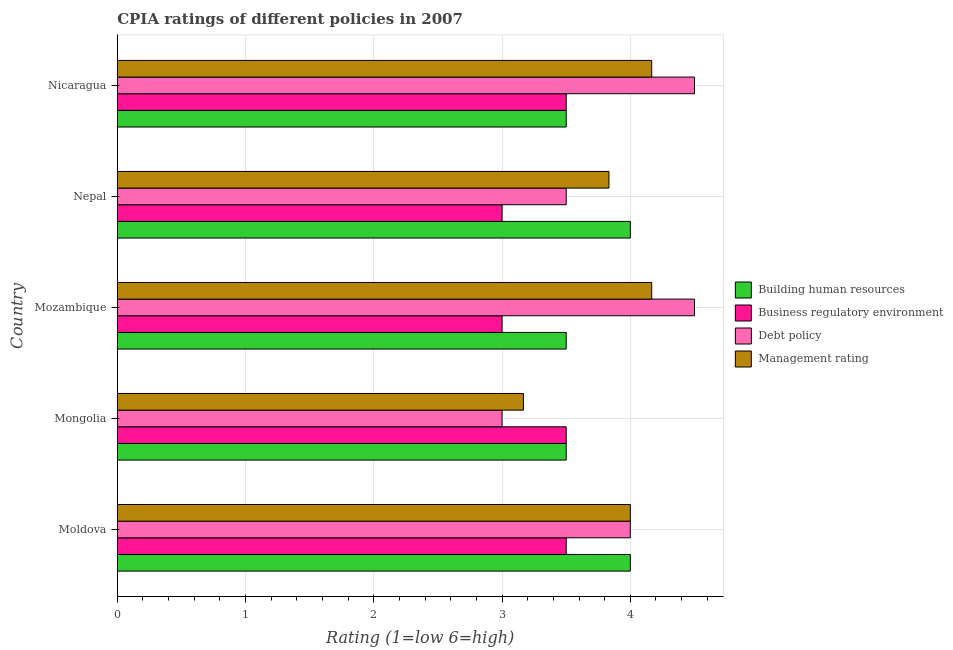How many different coloured bars are there?
Provide a short and direct response. 4. How many groups of bars are there?
Offer a very short reply. 5. Are the number of bars per tick equal to the number of legend labels?
Provide a short and direct response. Yes. How many bars are there on the 2nd tick from the top?
Offer a terse response. 4. How many bars are there on the 5th tick from the bottom?
Your answer should be very brief. 4. What is the label of the 1st group of bars from the top?
Make the answer very short. Nicaragua. What is the cpia rating of management in Moldova?
Keep it short and to the point. 4. Across all countries, what is the maximum cpia rating of building human resources?
Give a very brief answer. 4. In which country was the cpia rating of business regulatory environment maximum?
Make the answer very short. Moldova. In which country was the cpia rating of business regulatory environment minimum?
Offer a very short reply. Mozambique. What is the difference between the cpia rating of management in Mongolia and that in Nepal?
Offer a very short reply. -0.67. What is the difference between the cpia rating of business regulatory environment in Nepal and the cpia rating of building human resources in Nicaragua?
Give a very brief answer. -0.5. What is the average cpia rating of building human resources per country?
Offer a very short reply. 3.7. Is the cpia rating of debt policy in Mongolia less than that in Mozambique?
Provide a succinct answer. Yes. Is the difference between the cpia rating of management in Mongolia and Nicaragua greater than the difference between the cpia rating of business regulatory environment in Mongolia and Nicaragua?
Ensure brevity in your answer.  No. What is the difference between the highest and the second highest cpia rating of building human resources?
Give a very brief answer. 0. What is the difference between the highest and the lowest cpia rating of building human resources?
Offer a very short reply. 0.5. Is the sum of the cpia rating of building human resources in Mozambique and Nepal greater than the maximum cpia rating of management across all countries?
Provide a short and direct response. Yes. What does the 2nd bar from the top in Mongolia represents?
Your answer should be very brief. Debt policy. What does the 2nd bar from the bottom in Nepal represents?
Your answer should be compact. Business regulatory environment. How many bars are there?
Make the answer very short. 20. How many countries are there in the graph?
Provide a succinct answer. 5. What is the difference between two consecutive major ticks on the X-axis?
Provide a succinct answer. 1. Does the graph contain grids?
Your answer should be very brief. Yes. Where does the legend appear in the graph?
Provide a succinct answer. Center right. How are the legend labels stacked?
Your response must be concise. Vertical. What is the title of the graph?
Your response must be concise. CPIA ratings of different policies in 2007. What is the label or title of the X-axis?
Keep it short and to the point. Rating (1=low 6=high). What is the label or title of the Y-axis?
Your response must be concise. Country. What is the Rating (1=low 6=high) in Business regulatory environment in Moldova?
Provide a short and direct response. 3.5. What is the Rating (1=low 6=high) in Management rating in Moldova?
Give a very brief answer. 4. What is the Rating (1=low 6=high) in Building human resources in Mongolia?
Provide a succinct answer. 3.5. What is the Rating (1=low 6=high) of Management rating in Mongolia?
Give a very brief answer. 3.17. What is the Rating (1=low 6=high) in Debt policy in Mozambique?
Ensure brevity in your answer.  4.5. What is the Rating (1=low 6=high) of Management rating in Mozambique?
Keep it short and to the point. 4.17. What is the Rating (1=low 6=high) of Building human resources in Nepal?
Make the answer very short. 4. What is the Rating (1=low 6=high) of Debt policy in Nepal?
Give a very brief answer. 3.5. What is the Rating (1=low 6=high) of Management rating in Nepal?
Ensure brevity in your answer.  3.83. What is the Rating (1=low 6=high) of Building human resources in Nicaragua?
Ensure brevity in your answer.  3.5. What is the Rating (1=low 6=high) of Business regulatory environment in Nicaragua?
Ensure brevity in your answer.  3.5. What is the Rating (1=low 6=high) in Management rating in Nicaragua?
Ensure brevity in your answer.  4.17. Across all countries, what is the maximum Rating (1=low 6=high) of Management rating?
Provide a short and direct response. 4.17. Across all countries, what is the minimum Rating (1=low 6=high) in Management rating?
Keep it short and to the point. 3.17. What is the total Rating (1=low 6=high) of Building human resources in the graph?
Your response must be concise. 18.5. What is the total Rating (1=low 6=high) of Business regulatory environment in the graph?
Give a very brief answer. 16.5. What is the total Rating (1=low 6=high) in Debt policy in the graph?
Offer a very short reply. 19.5. What is the total Rating (1=low 6=high) in Management rating in the graph?
Make the answer very short. 19.33. What is the difference between the Rating (1=low 6=high) in Debt policy in Moldova and that in Mongolia?
Offer a terse response. 1. What is the difference between the Rating (1=low 6=high) of Building human resources in Moldova and that in Mozambique?
Give a very brief answer. 0.5. What is the difference between the Rating (1=low 6=high) in Debt policy in Moldova and that in Mozambique?
Keep it short and to the point. -0.5. What is the difference between the Rating (1=low 6=high) of Business regulatory environment in Moldova and that in Nepal?
Offer a terse response. 0.5. What is the difference between the Rating (1=low 6=high) of Debt policy in Moldova and that in Nepal?
Your response must be concise. 0.5. What is the difference between the Rating (1=low 6=high) in Management rating in Moldova and that in Nepal?
Your answer should be compact. 0.17. What is the difference between the Rating (1=low 6=high) in Business regulatory environment in Moldova and that in Nicaragua?
Make the answer very short. 0. What is the difference between the Rating (1=low 6=high) of Debt policy in Moldova and that in Nicaragua?
Provide a succinct answer. -0.5. What is the difference between the Rating (1=low 6=high) of Management rating in Moldova and that in Nicaragua?
Your answer should be very brief. -0.17. What is the difference between the Rating (1=low 6=high) in Business regulatory environment in Mongolia and that in Mozambique?
Provide a succinct answer. 0.5. What is the difference between the Rating (1=low 6=high) of Building human resources in Mongolia and that in Nepal?
Provide a short and direct response. -0.5. What is the difference between the Rating (1=low 6=high) of Debt policy in Mongolia and that in Nepal?
Your response must be concise. -0.5. What is the difference between the Rating (1=low 6=high) of Management rating in Mongolia and that in Nepal?
Keep it short and to the point. -0.67. What is the difference between the Rating (1=low 6=high) of Business regulatory environment in Mongolia and that in Nicaragua?
Your response must be concise. 0. What is the difference between the Rating (1=low 6=high) of Debt policy in Mongolia and that in Nicaragua?
Offer a terse response. -1.5. What is the difference between the Rating (1=low 6=high) of Building human resources in Mozambique and that in Nepal?
Give a very brief answer. -0.5. What is the difference between the Rating (1=low 6=high) in Business regulatory environment in Mozambique and that in Nepal?
Keep it short and to the point. 0. What is the difference between the Rating (1=low 6=high) in Building human resources in Moldova and the Rating (1=low 6=high) in Business regulatory environment in Mongolia?
Provide a short and direct response. 0.5. What is the difference between the Rating (1=low 6=high) of Debt policy in Moldova and the Rating (1=low 6=high) of Management rating in Mongolia?
Your answer should be very brief. 0.83. What is the difference between the Rating (1=low 6=high) in Building human resources in Moldova and the Rating (1=low 6=high) in Debt policy in Mozambique?
Your answer should be compact. -0.5. What is the difference between the Rating (1=low 6=high) of Building human resources in Moldova and the Rating (1=low 6=high) of Management rating in Mozambique?
Your answer should be very brief. -0.17. What is the difference between the Rating (1=low 6=high) of Business regulatory environment in Moldova and the Rating (1=low 6=high) of Debt policy in Mozambique?
Offer a very short reply. -1. What is the difference between the Rating (1=low 6=high) in Debt policy in Moldova and the Rating (1=low 6=high) in Management rating in Mozambique?
Provide a succinct answer. -0.17. What is the difference between the Rating (1=low 6=high) of Building human resources in Moldova and the Rating (1=low 6=high) of Business regulatory environment in Nepal?
Keep it short and to the point. 1. What is the difference between the Rating (1=low 6=high) of Building human resources in Moldova and the Rating (1=low 6=high) of Management rating in Nepal?
Ensure brevity in your answer.  0.17. What is the difference between the Rating (1=low 6=high) of Business regulatory environment in Moldova and the Rating (1=low 6=high) of Debt policy in Nepal?
Give a very brief answer. 0. What is the difference between the Rating (1=low 6=high) of Building human resources in Moldova and the Rating (1=low 6=high) of Business regulatory environment in Nicaragua?
Provide a succinct answer. 0.5. What is the difference between the Rating (1=low 6=high) in Building human resources in Moldova and the Rating (1=low 6=high) in Management rating in Nicaragua?
Your answer should be very brief. -0.17. What is the difference between the Rating (1=low 6=high) of Business regulatory environment in Moldova and the Rating (1=low 6=high) of Debt policy in Nicaragua?
Ensure brevity in your answer.  -1. What is the difference between the Rating (1=low 6=high) of Business regulatory environment in Moldova and the Rating (1=low 6=high) of Management rating in Nicaragua?
Make the answer very short. -0.67. What is the difference between the Rating (1=low 6=high) of Debt policy in Moldova and the Rating (1=low 6=high) of Management rating in Nicaragua?
Your response must be concise. -0.17. What is the difference between the Rating (1=low 6=high) in Building human resources in Mongolia and the Rating (1=low 6=high) in Business regulatory environment in Mozambique?
Ensure brevity in your answer.  0.5. What is the difference between the Rating (1=low 6=high) of Debt policy in Mongolia and the Rating (1=low 6=high) of Management rating in Mozambique?
Provide a succinct answer. -1.17. What is the difference between the Rating (1=low 6=high) in Building human resources in Mongolia and the Rating (1=low 6=high) in Business regulatory environment in Nepal?
Offer a terse response. 0.5. What is the difference between the Rating (1=low 6=high) in Building human resources in Mongolia and the Rating (1=low 6=high) in Management rating in Nepal?
Your answer should be compact. -0.33. What is the difference between the Rating (1=low 6=high) of Business regulatory environment in Mongolia and the Rating (1=low 6=high) of Debt policy in Nepal?
Make the answer very short. 0. What is the difference between the Rating (1=low 6=high) in Building human resources in Mongolia and the Rating (1=low 6=high) in Business regulatory environment in Nicaragua?
Make the answer very short. 0. What is the difference between the Rating (1=low 6=high) of Building human resources in Mongolia and the Rating (1=low 6=high) of Debt policy in Nicaragua?
Provide a short and direct response. -1. What is the difference between the Rating (1=low 6=high) of Debt policy in Mongolia and the Rating (1=low 6=high) of Management rating in Nicaragua?
Provide a succinct answer. -1.17. What is the difference between the Rating (1=low 6=high) in Building human resources in Mozambique and the Rating (1=low 6=high) in Management rating in Nepal?
Your answer should be very brief. -0.33. What is the difference between the Rating (1=low 6=high) of Business regulatory environment in Mozambique and the Rating (1=low 6=high) of Management rating in Nepal?
Offer a terse response. -0.83. What is the difference between the Rating (1=low 6=high) in Business regulatory environment in Mozambique and the Rating (1=low 6=high) in Debt policy in Nicaragua?
Your response must be concise. -1.5. What is the difference between the Rating (1=low 6=high) in Business regulatory environment in Mozambique and the Rating (1=low 6=high) in Management rating in Nicaragua?
Make the answer very short. -1.17. What is the difference between the Rating (1=low 6=high) of Building human resources in Nepal and the Rating (1=low 6=high) of Management rating in Nicaragua?
Your response must be concise. -0.17. What is the difference between the Rating (1=low 6=high) of Business regulatory environment in Nepal and the Rating (1=low 6=high) of Debt policy in Nicaragua?
Your answer should be compact. -1.5. What is the difference between the Rating (1=low 6=high) in Business regulatory environment in Nepal and the Rating (1=low 6=high) in Management rating in Nicaragua?
Your answer should be compact. -1.17. What is the difference between the Rating (1=low 6=high) of Debt policy in Nepal and the Rating (1=low 6=high) of Management rating in Nicaragua?
Provide a short and direct response. -0.67. What is the average Rating (1=low 6=high) in Debt policy per country?
Give a very brief answer. 3.9. What is the average Rating (1=low 6=high) of Management rating per country?
Your answer should be compact. 3.87. What is the difference between the Rating (1=low 6=high) of Building human resources and Rating (1=low 6=high) of Business regulatory environment in Moldova?
Your response must be concise. 0.5. What is the difference between the Rating (1=low 6=high) in Building human resources and Rating (1=low 6=high) in Debt policy in Moldova?
Provide a short and direct response. 0. What is the difference between the Rating (1=low 6=high) of Debt policy and Rating (1=low 6=high) of Management rating in Moldova?
Your response must be concise. 0. What is the difference between the Rating (1=low 6=high) of Business regulatory environment and Rating (1=low 6=high) of Debt policy in Mongolia?
Make the answer very short. 0.5. What is the difference between the Rating (1=low 6=high) of Business regulatory environment and Rating (1=low 6=high) of Management rating in Mongolia?
Make the answer very short. 0.33. What is the difference between the Rating (1=low 6=high) in Debt policy and Rating (1=low 6=high) in Management rating in Mongolia?
Keep it short and to the point. -0.17. What is the difference between the Rating (1=low 6=high) in Building human resources and Rating (1=low 6=high) in Business regulatory environment in Mozambique?
Your response must be concise. 0.5. What is the difference between the Rating (1=low 6=high) in Building human resources and Rating (1=low 6=high) in Debt policy in Mozambique?
Provide a succinct answer. -1. What is the difference between the Rating (1=low 6=high) of Building human resources and Rating (1=low 6=high) of Management rating in Mozambique?
Ensure brevity in your answer.  -0.67. What is the difference between the Rating (1=low 6=high) of Business regulatory environment and Rating (1=low 6=high) of Management rating in Mozambique?
Provide a succinct answer. -1.17. What is the difference between the Rating (1=low 6=high) of Debt policy and Rating (1=low 6=high) of Management rating in Mozambique?
Your answer should be very brief. 0.33. What is the difference between the Rating (1=low 6=high) of Building human resources and Rating (1=low 6=high) of Debt policy in Nepal?
Provide a short and direct response. 0.5. What is the difference between the Rating (1=low 6=high) of Building human resources and Rating (1=low 6=high) of Management rating in Nepal?
Offer a terse response. 0.17. What is the difference between the Rating (1=low 6=high) in Business regulatory environment and Rating (1=low 6=high) in Debt policy in Nepal?
Your answer should be compact. -0.5. What is the difference between the Rating (1=low 6=high) in Building human resources and Rating (1=low 6=high) in Business regulatory environment in Nicaragua?
Ensure brevity in your answer.  0. What is the difference between the Rating (1=low 6=high) in Building human resources and Rating (1=low 6=high) in Debt policy in Nicaragua?
Ensure brevity in your answer.  -1. What is the difference between the Rating (1=low 6=high) in Building human resources and Rating (1=low 6=high) in Management rating in Nicaragua?
Provide a succinct answer. -0.67. What is the difference between the Rating (1=low 6=high) of Business regulatory environment and Rating (1=low 6=high) of Management rating in Nicaragua?
Ensure brevity in your answer.  -0.67. What is the ratio of the Rating (1=low 6=high) of Business regulatory environment in Moldova to that in Mongolia?
Your answer should be compact. 1. What is the ratio of the Rating (1=low 6=high) of Debt policy in Moldova to that in Mongolia?
Keep it short and to the point. 1.33. What is the ratio of the Rating (1=low 6=high) of Management rating in Moldova to that in Mongolia?
Provide a short and direct response. 1.26. What is the ratio of the Rating (1=low 6=high) in Business regulatory environment in Moldova to that in Nepal?
Provide a short and direct response. 1.17. What is the ratio of the Rating (1=low 6=high) of Management rating in Moldova to that in Nepal?
Provide a short and direct response. 1.04. What is the ratio of the Rating (1=low 6=high) of Business regulatory environment in Moldova to that in Nicaragua?
Give a very brief answer. 1. What is the ratio of the Rating (1=low 6=high) in Building human resources in Mongolia to that in Mozambique?
Your answer should be compact. 1. What is the ratio of the Rating (1=low 6=high) of Business regulatory environment in Mongolia to that in Mozambique?
Make the answer very short. 1.17. What is the ratio of the Rating (1=low 6=high) of Management rating in Mongolia to that in Mozambique?
Ensure brevity in your answer.  0.76. What is the ratio of the Rating (1=low 6=high) in Building human resources in Mongolia to that in Nepal?
Provide a short and direct response. 0.88. What is the ratio of the Rating (1=low 6=high) of Business regulatory environment in Mongolia to that in Nepal?
Your answer should be compact. 1.17. What is the ratio of the Rating (1=low 6=high) of Debt policy in Mongolia to that in Nepal?
Provide a short and direct response. 0.86. What is the ratio of the Rating (1=low 6=high) in Management rating in Mongolia to that in Nepal?
Offer a terse response. 0.83. What is the ratio of the Rating (1=low 6=high) of Management rating in Mongolia to that in Nicaragua?
Provide a succinct answer. 0.76. What is the ratio of the Rating (1=low 6=high) in Building human resources in Mozambique to that in Nepal?
Your answer should be very brief. 0.88. What is the ratio of the Rating (1=low 6=high) of Debt policy in Mozambique to that in Nepal?
Provide a succinct answer. 1.29. What is the ratio of the Rating (1=low 6=high) in Management rating in Mozambique to that in Nepal?
Give a very brief answer. 1.09. What is the ratio of the Rating (1=low 6=high) in Business regulatory environment in Mozambique to that in Nicaragua?
Offer a very short reply. 0.86. What is the ratio of the Rating (1=low 6=high) in Management rating in Mozambique to that in Nicaragua?
Provide a succinct answer. 1. What is the ratio of the Rating (1=low 6=high) in Building human resources in Nepal to that in Nicaragua?
Your answer should be compact. 1.14. What is the ratio of the Rating (1=low 6=high) of Business regulatory environment in Nepal to that in Nicaragua?
Ensure brevity in your answer.  0.86. What is the difference between the highest and the second highest Rating (1=low 6=high) of Building human resources?
Provide a short and direct response. 0. What is the difference between the highest and the second highest Rating (1=low 6=high) in Debt policy?
Make the answer very short. 0. What is the difference between the highest and the second highest Rating (1=low 6=high) in Management rating?
Provide a short and direct response. 0. What is the difference between the highest and the lowest Rating (1=low 6=high) in Business regulatory environment?
Offer a very short reply. 0.5. What is the difference between the highest and the lowest Rating (1=low 6=high) of Debt policy?
Make the answer very short. 1.5. 